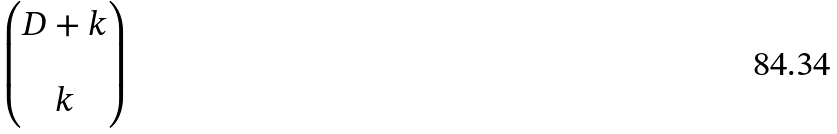<formula> <loc_0><loc_0><loc_500><loc_500>\begin{pmatrix} D + k \\ \\ k \end{pmatrix}</formula> 